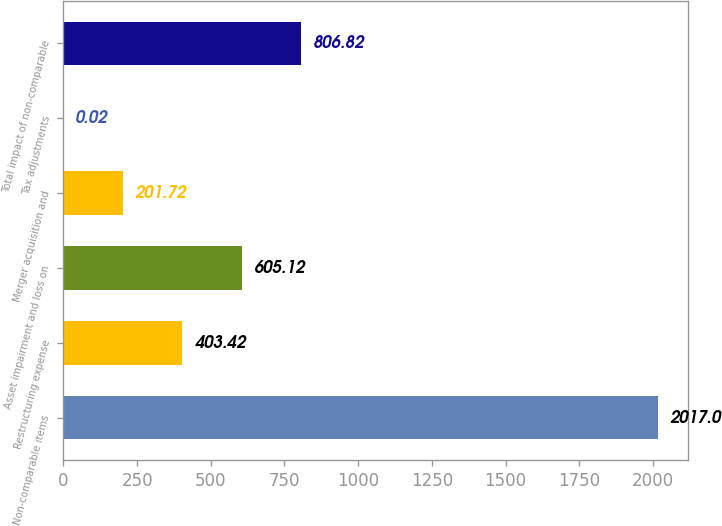Convert chart. <chart><loc_0><loc_0><loc_500><loc_500><bar_chart><fcel>Non-comparable items<fcel>Restructuring expense<fcel>Asset impairment and loss on<fcel>Merger acquisition and<fcel>Tax adjustments<fcel>Total impact of non-comparable<nl><fcel>2017<fcel>403.42<fcel>605.12<fcel>201.72<fcel>0.02<fcel>806.82<nl></chart> 